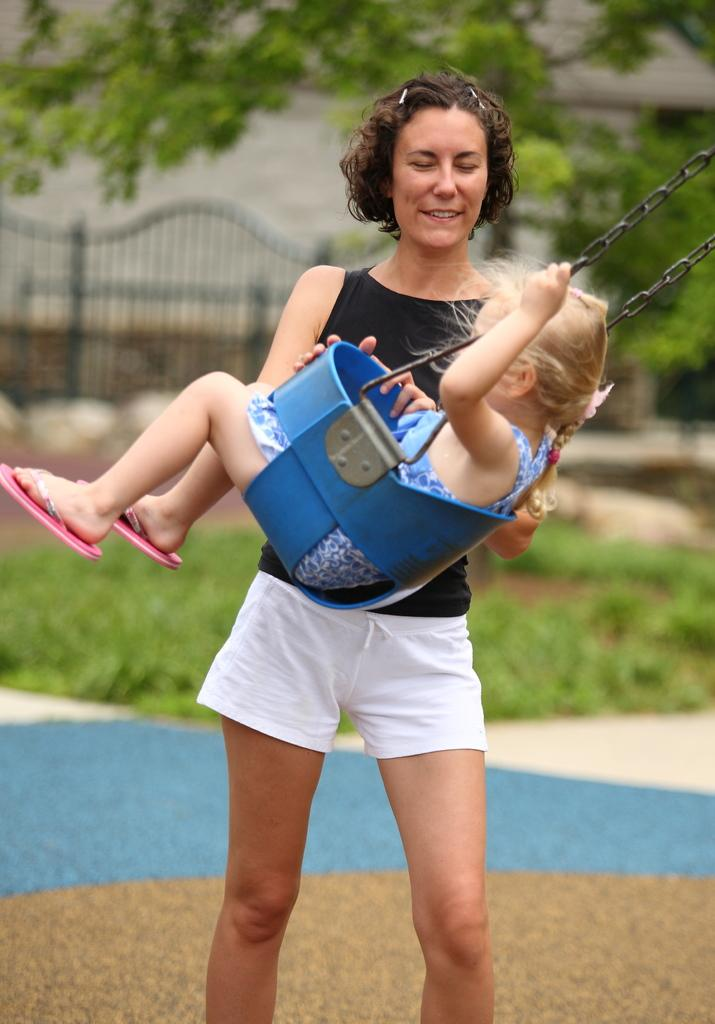What is the woman doing in the image? The woman is standing in the image. What is the kid doing in the image? The kid is sitting in a swing in the image. What type of vegetation can be seen in the image? There are plants and a tree in the image. What architectural features are visible in the background of the image? There is a wall and a gate in the background of the image. Where is the drain located in the image? There is no drain present in the image. What type of cord is being used by the woman in the image? There is no cord visible in the image; the woman is simply standing. 